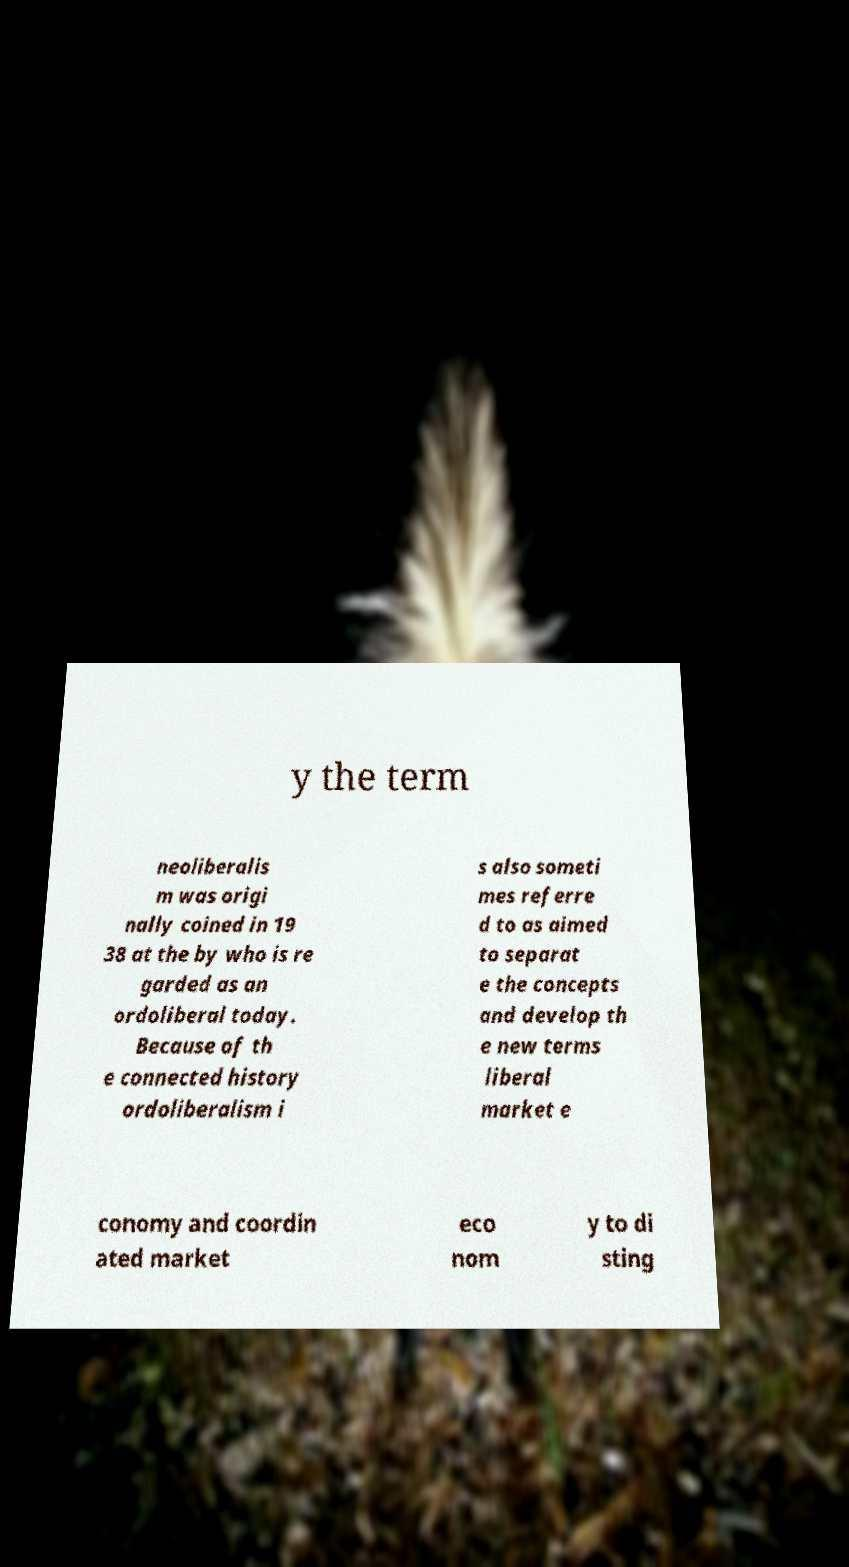Can you read and provide the text displayed in the image?This photo seems to have some interesting text. Can you extract and type it out for me? y the term neoliberalis m was origi nally coined in 19 38 at the by who is re garded as an ordoliberal today. Because of th e connected history ordoliberalism i s also someti mes referre d to as aimed to separat e the concepts and develop th e new terms liberal market e conomy and coordin ated market eco nom y to di sting 